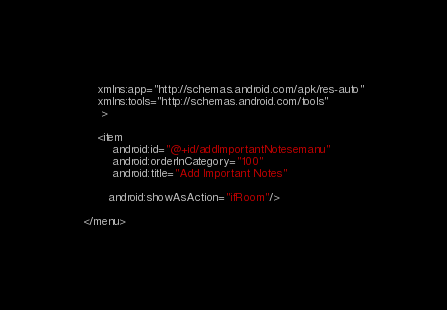<code> <loc_0><loc_0><loc_500><loc_500><_XML_>    xmlns:app="http://schemas.android.com/apk/res-auto"
    xmlns:tools="http://schemas.android.com/tools"
     >

    <item
        android:id="@+id/addImportantNotesemanu"
        android:orderInCategory="100"
        android:title="Add Important Notes"
        
       android:showAsAction="ifRoom"/>
    
</menu>
</code> 